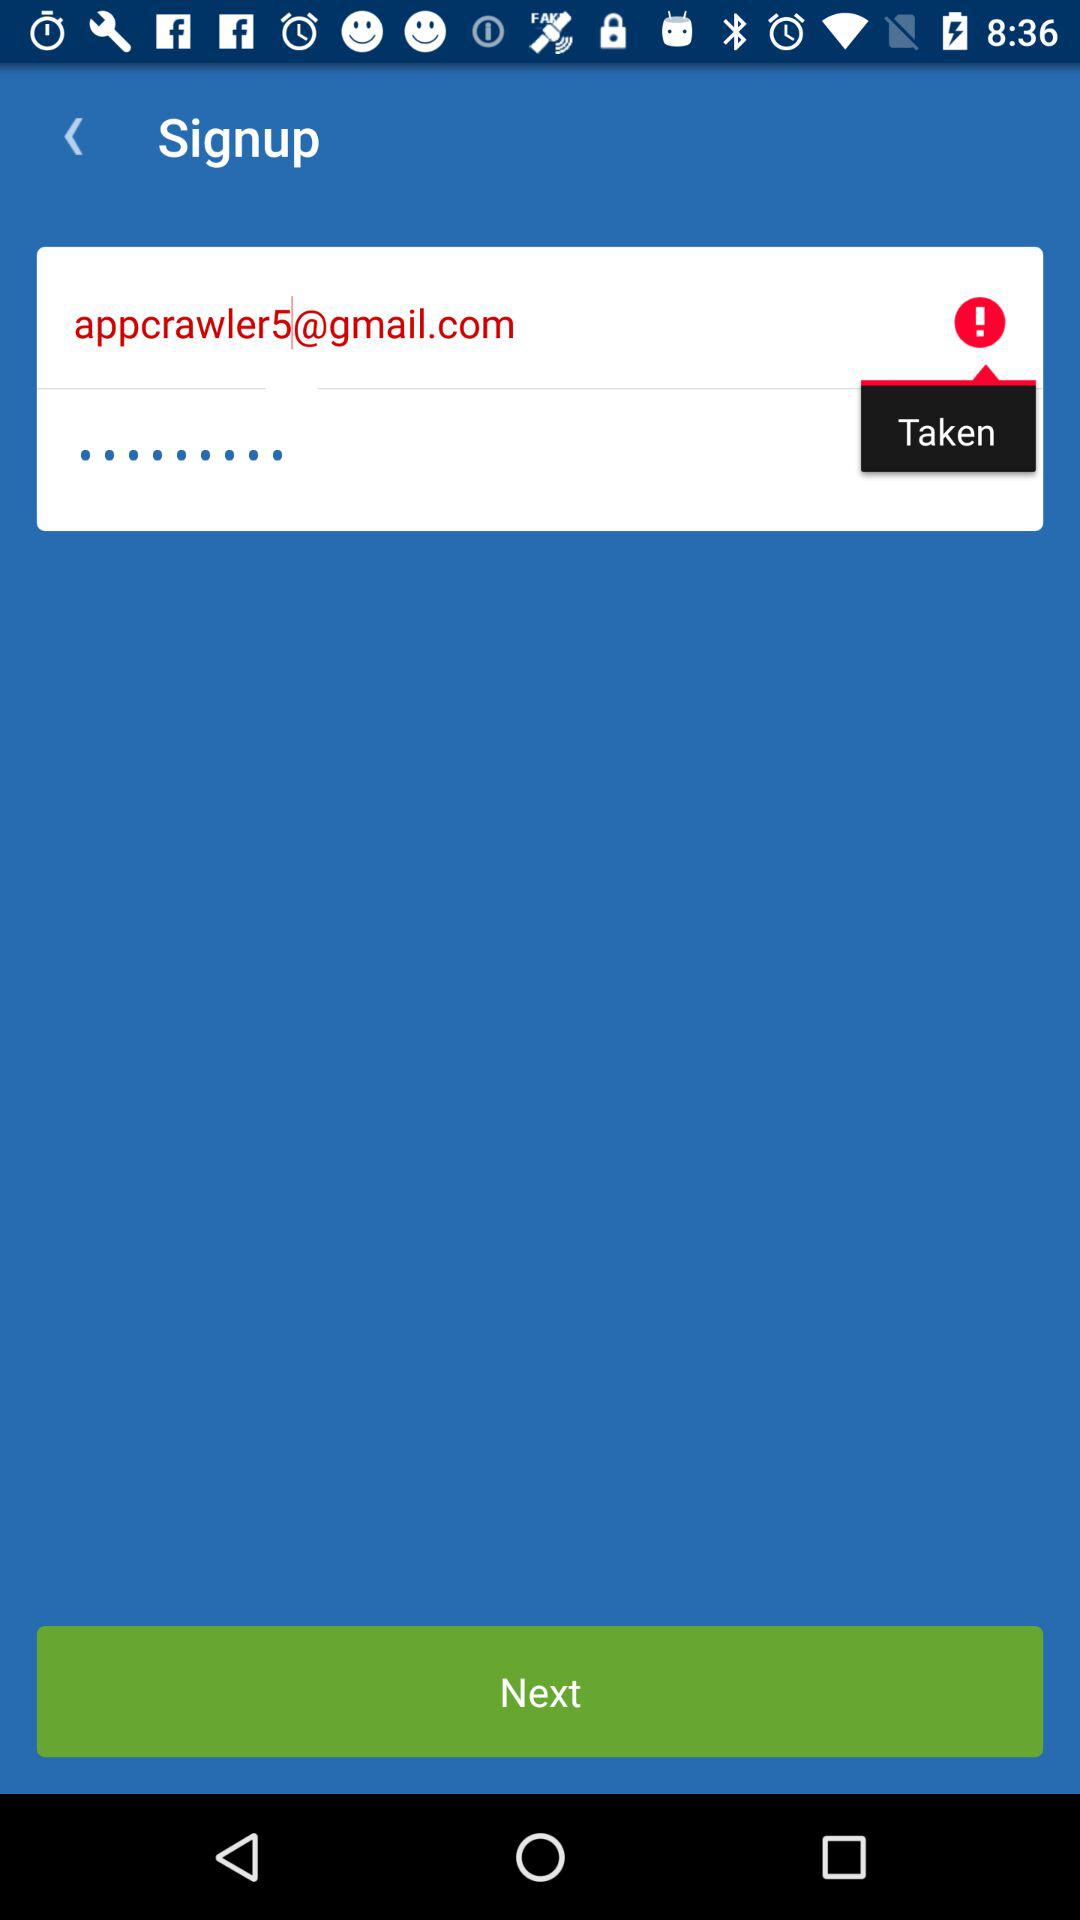What is the E-mail address? The E-mail address is appcrawler5@gmail.com. 